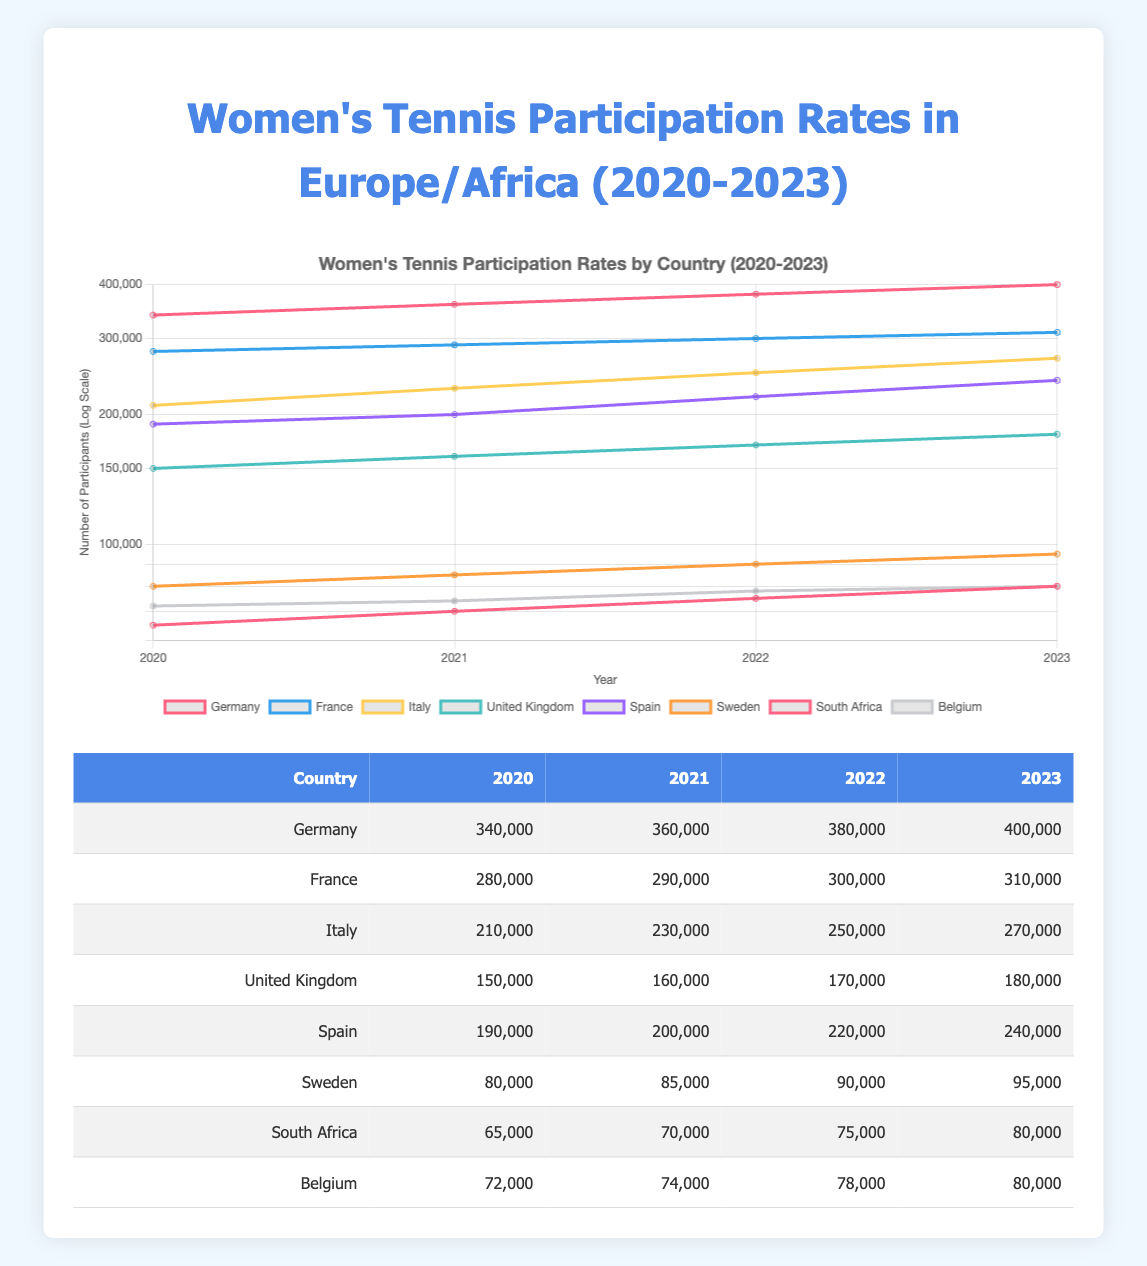What was the participation rate for women’s tennis in Spain in 2022? According to the table, the participation rate for Spain in 2022 is reported as 220,000.
Answer: 220,000 Which country had the highest number of participants in 2023? Referring to the table, Germany had the highest number of participants in 2023 with 400,000.
Answer: Germany What is the difference in participation rates between Italy in 2020 and 2023? The participation rate for Italy in 2020 is 210,000, while in 2023 it is 270,000. The difference is calculated as 270,000 - 210,000 = 60,000.
Answer: 60,000 Did Belgium's participation rate increase every year from 2020 to 2023? By examining the table, the participation rates for Belgium are 72,000 (2020), 74,000 (2021), 78,000 (2022), and 80,000 (2023), indicating that the rate increased each year.
Answer: Yes What is the average participation rate for women’s tennis in South Africa from 2020 to 2023? The participation rates for South Africa from 2020 to 2023 are 65,000, 70,000, 75,000, and 80,000. Summing these rates gives 65,000 + 70,000 + 75,000 + 80,000 = 290,000. Dividing this sum by 4 (the number of years) results in an average of 290,000 / 4 = 72,500.
Answer: 72,500 Which country had the most significant increase in participation from 2020 to 2023? To determine this, we calculate the increase for each country: Germany: 400,000 - 340,000 = 60,000; France: 310,000 - 280,000 = 30,000; Italy: 270,000 - 210,000 = 60,000; United Kingdom: 180,000 - 150,000 = 30,000; Spain: 240,000 - 190,000 = 50,000; Sweden: 95,000 - 80,000 = 15,000; South Africa: 80,000 - 65,000 = 15,000; Belgium: 80,000 - 72,000 = 8,000. The largest increases are 60,000 for both Germany and Italy, indicating a tie.
Answer: Germany and Italy Is the participation rate for Sweden greater than that for South Africa in 2021? From the table, Sweden's participation rate in 2021 is 85,000, while South Africa's is 70,000. Since 85,000 is greater than 70,000, the statement is true.
Answer: Yes What was the participation rate for Italy in 2021, and how does it compare to France in the same year? The participation rate for Italy in 2021 is 230,000, while France's in the same year is 290,000. Comparison shows that France had a higher rate than Italy.
Answer: Italy: 230,000; France: 290,000; France is higher 